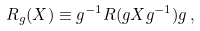Convert formula to latex. <formula><loc_0><loc_0><loc_500><loc_500>R _ { g } ( X ) \equiv g ^ { - 1 } R ( g X g ^ { - 1 } ) g \, ,</formula> 